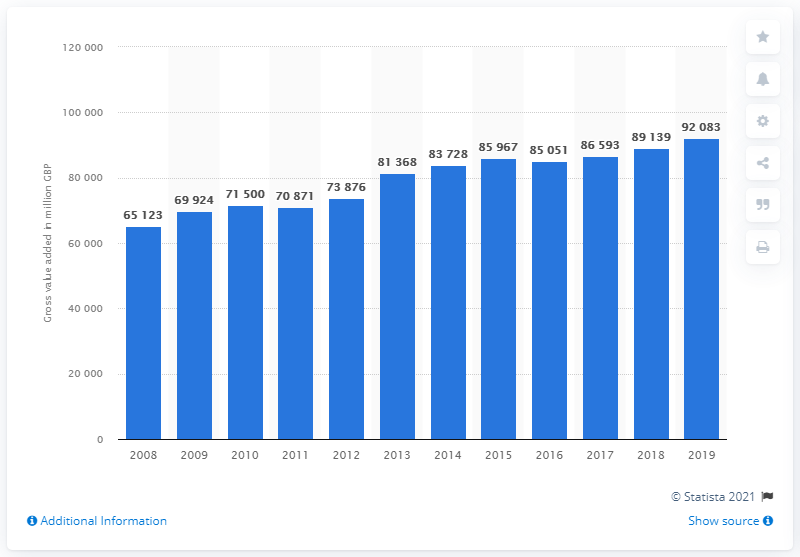Highlight a few significant elements in this photo. In 2012, the retail trade of goods made a significant contribution to the Gross Value Added (GVA) of the Non-Financial Business Economy of the United Kingdom, accounting for 738,760. In 2019, the Gross Value Added (GVA) of the retail trade in the UK amounted to 92,083. 